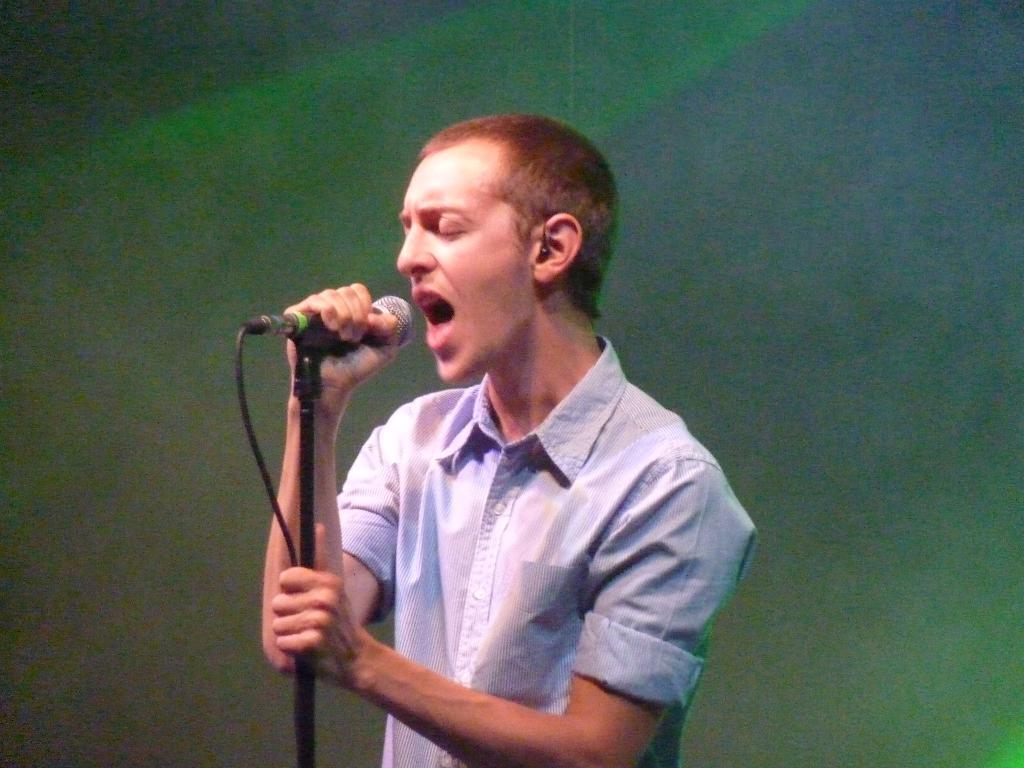What is the color of the background in the image? The background of the image is green. What is the main subject of the image? There is a boy in the middle of the image. What is the boy doing in the image? The boy is singing. What object is the boy holding in the image? The boy is holding a mic in his hands. Can you see any snow in the image? There is no snow present in the image. What type of hand is the boy using to hold the mic? The boy is using his human hand to hold the mic, as there are no other types of hands mentioned or visible in the image. 